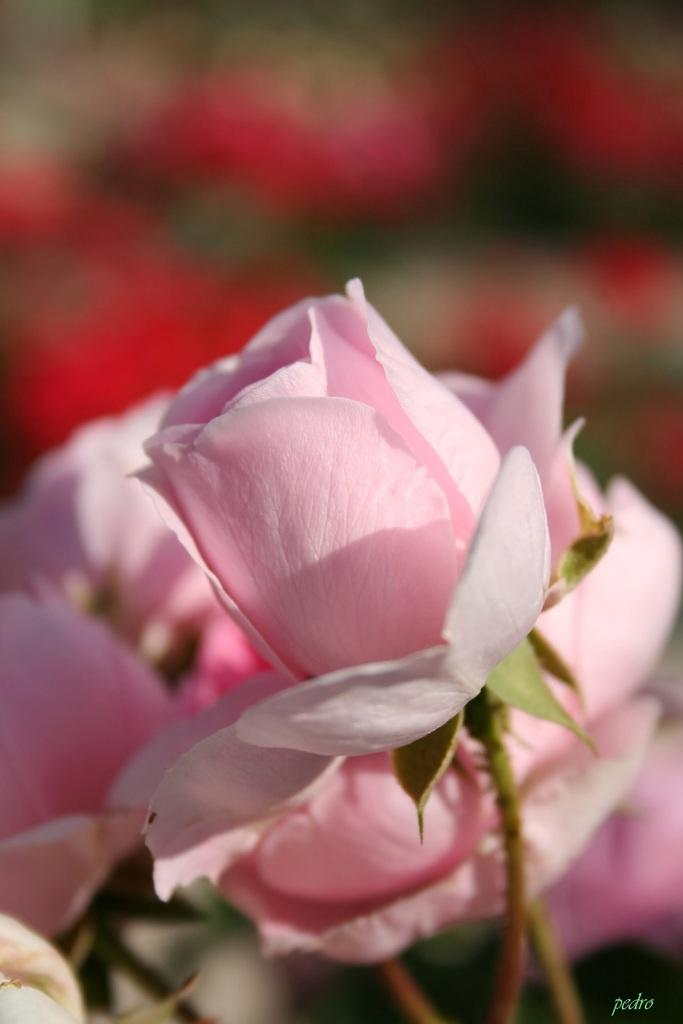What type of flowers are in the image? There are pink roses in the image. How would you describe the background of the image? The background of the image is blurred. Is there any additional information or branding in the image? Yes, there is a watermark in the right bottom corner of the image. What is the weight of the jeans worn by the person in the image? There is no person or jeans present in the image; it features pink roses and a blurred background. 